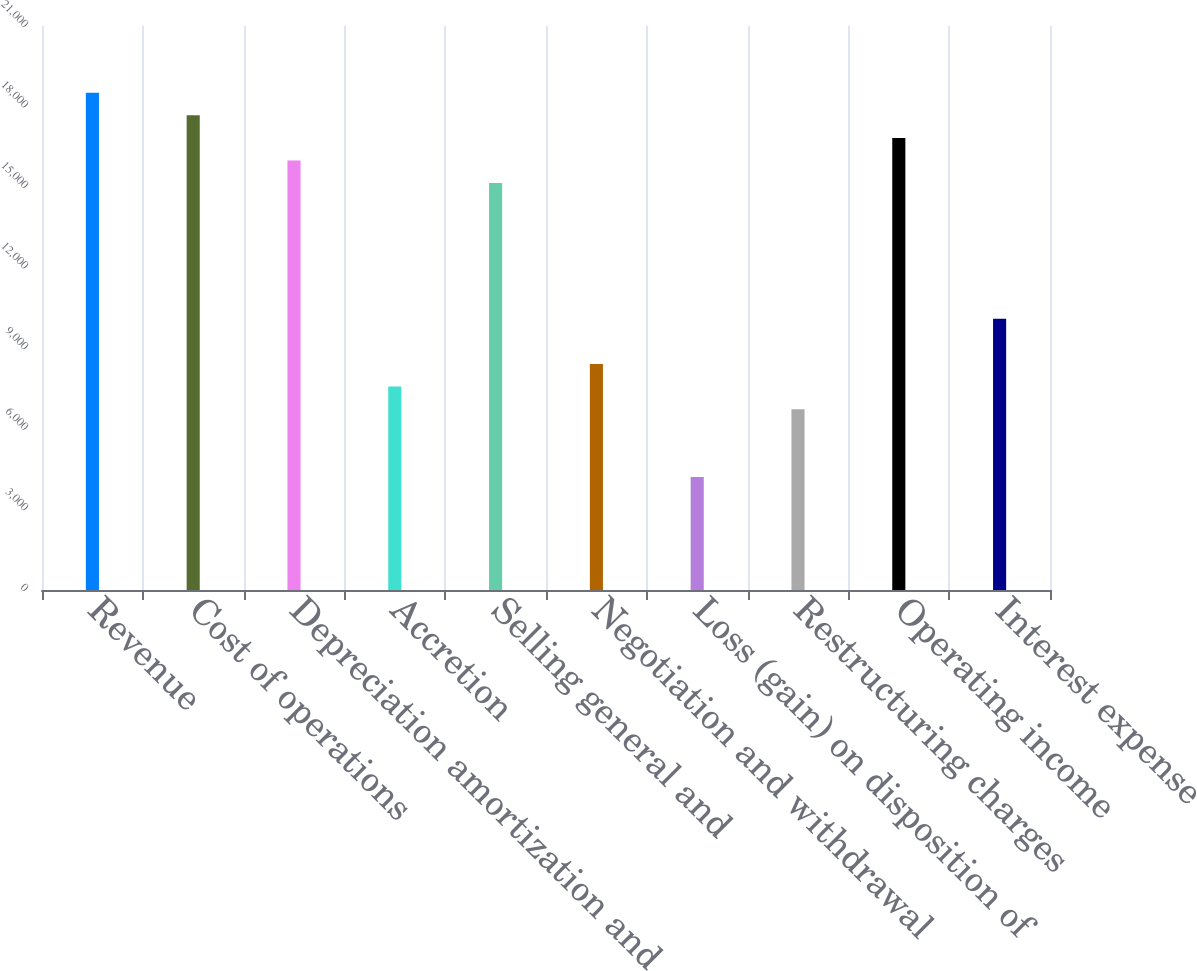Convert chart to OTSL. <chart><loc_0><loc_0><loc_500><loc_500><bar_chart><fcel>Revenue<fcel>Cost of operations<fcel>Depreciation amortization and<fcel>Accretion<fcel>Selling general and<fcel>Negotiation and withdrawal<fcel>Loss (gain) on disposition of<fcel>Restructuring charges<fcel>Operating income<fcel>Interest expense<nl><fcel>18517.6<fcel>17675.9<fcel>15992.5<fcel>7575.5<fcel>15150.8<fcel>8417.2<fcel>4208.7<fcel>6733.8<fcel>16834.2<fcel>10100.6<nl></chart> 